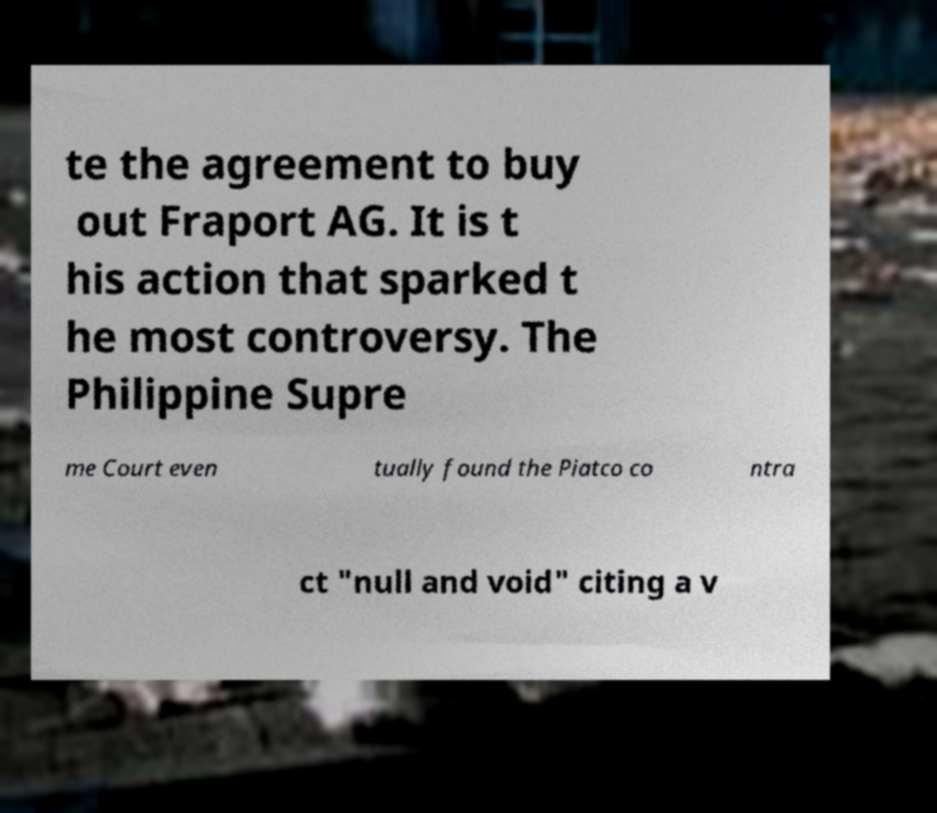Could you extract and type out the text from this image? te the agreement to buy out Fraport AG. It is t his action that sparked t he most controversy. The Philippine Supre me Court even tually found the Piatco co ntra ct "null and void" citing a v 